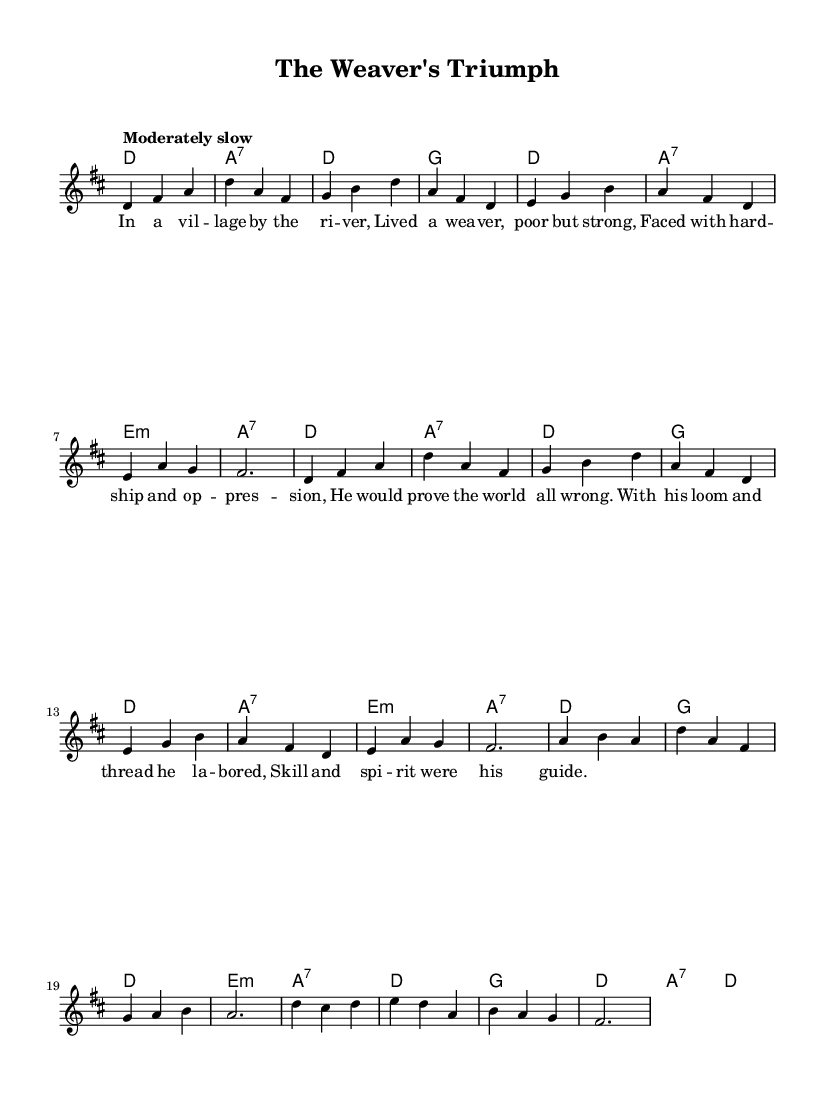What is the key signature of this music? The key signature is D major, which has two sharps (F# and C#). We determine the key signature by looking at the beginning of the staff, which shows the sharp symbols.
Answer: D major What is the time signature of this music? The time signature is 3/4, indicated by the markings found at the beginning of the piece. This means there are three beats per measure, with each beat being a quarter note.
Answer: 3/4 What is the tempo marking for this piece? The tempo marking is "Moderately slow," which describes how quickly the music should be played. This marking is usually found at the beginning of the piece.
Answer: Moderately slow How many measures are in the melody section? The melody section contains 8 measures, counted by looking at the separation of musical phrases delineated by vertical lines (bar lines).
Answer: 8 What is the primary theme of the lyrics? The primary theme of the lyrics revolves around overcoming hardship, specifically a weaver proving the world wrong despite adversity. This can be gleaned from the lyrics discussing the weaver's strength and labor.
Answer: Overcoming hardship How many different chords are used in the harmony section? There are five distinct chords used in the harmony section: D, A7, G, Em, and A. By analyzing the chord symbols shown along with the melody, we determine the variety of chords present.
Answer: Five 